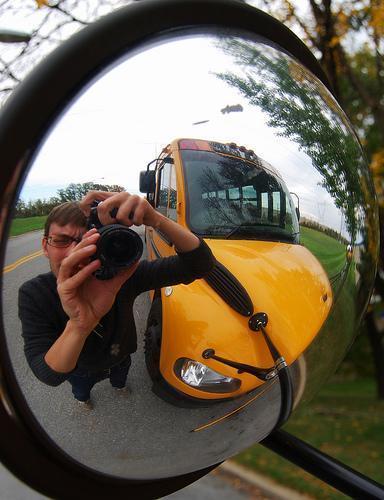How many people are in the picture?
Give a very brief answer. 1. 